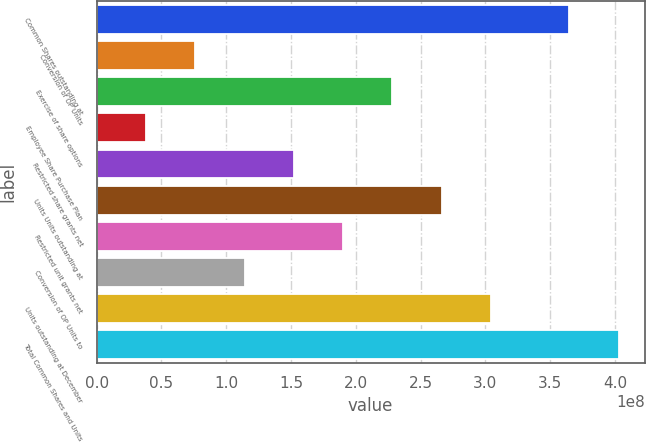Convert chart to OTSL. <chart><loc_0><loc_0><loc_500><loc_500><bar_chart><fcel>Common Shares outstanding at<fcel>Conversion of OP Units<fcel>Exercise of share options<fcel>Employee Share Purchase Plan<fcel>Restricted share grants net<fcel>Units Units outstanding at<fcel>Restricted unit grants net<fcel>Conversion of OP Units to<fcel>Units outstanding at December<fcel>Total Common Shares and Units<nl><fcel>3.64755e+08<fcel>7.60994e+07<fcel>2.28298e+08<fcel>3.80497e+07<fcel>1.52199e+08<fcel>2.66348e+08<fcel>1.90249e+08<fcel>1.14149e+08<fcel>3.04398e+08<fcel>4.02805e+08<nl></chart> 